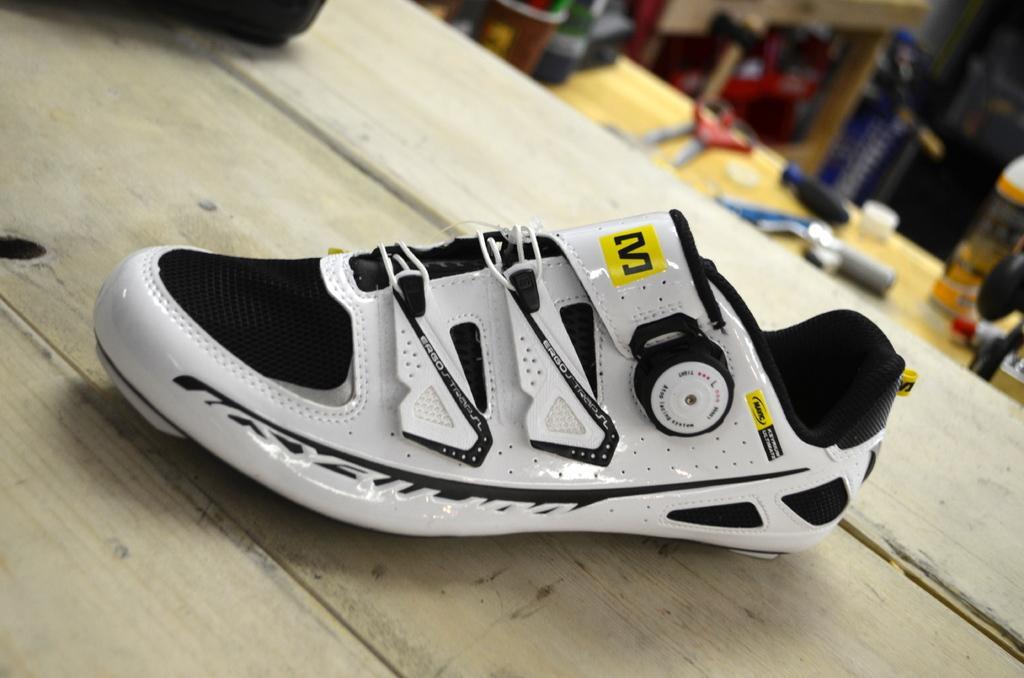Can you describe this image briefly? In the center of the image there is a show on the table. In the background of the image there are objects placed on the table. 